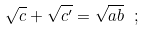<formula> <loc_0><loc_0><loc_500><loc_500>\sqrt { c } + \sqrt { c ^ { \prime } } = \sqrt { a b } \ ;</formula> 